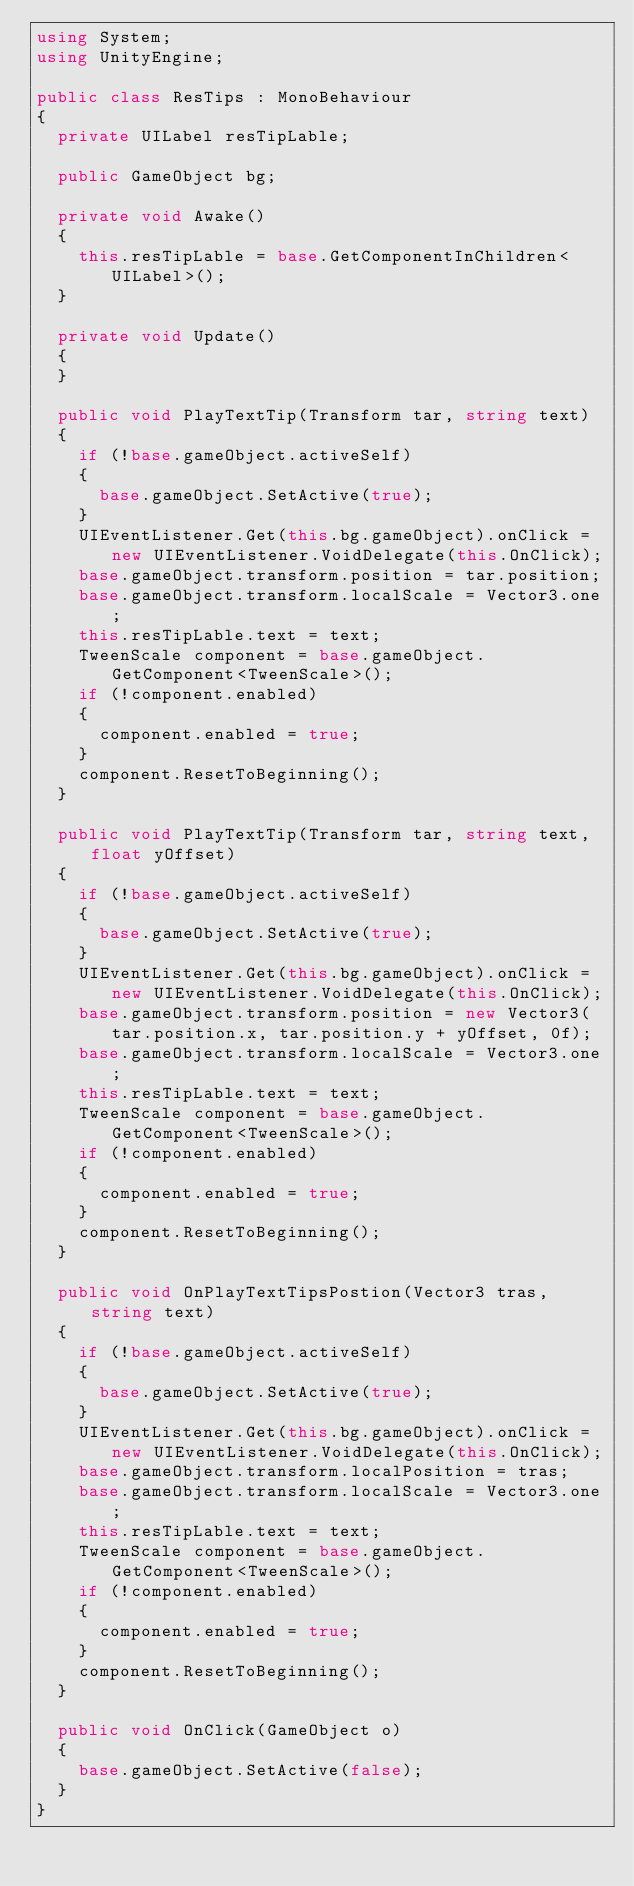Convert code to text. <code><loc_0><loc_0><loc_500><loc_500><_C#_>using System;
using UnityEngine;

public class ResTips : MonoBehaviour
{
	private UILabel resTipLable;

	public GameObject bg;

	private void Awake()
	{
		this.resTipLable = base.GetComponentInChildren<UILabel>();
	}

	private void Update()
	{
	}

	public void PlayTextTip(Transform tar, string text)
	{
		if (!base.gameObject.activeSelf)
		{
			base.gameObject.SetActive(true);
		}
		UIEventListener.Get(this.bg.gameObject).onClick = new UIEventListener.VoidDelegate(this.OnClick);
		base.gameObject.transform.position = tar.position;
		base.gameObject.transform.localScale = Vector3.one;
		this.resTipLable.text = text;
		TweenScale component = base.gameObject.GetComponent<TweenScale>();
		if (!component.enabled)
		{
			component.enabled = true;
		}
		component.ResetToBeginning();
	}

	public void PlayTextTip(Transform tar, string text, float yOffset)
	{
		if (!base.gameObject.activeSelf)
		{
			base.gameObject.SetActive(true);
		}
		UIEventListener.Get(this.bg.gameObject).onClick = new UIEventListener.VoidDelegate(this.OnClick);
		base.gameObject.transform.position = new Vector3(tar.position.x, tar.position.y + yOffset, 0f);
		base.gameObject.transform.localScale = Vector3.one;
		this.resTipLable.text = text;
		TweenScale component = base.gameObject.GetComponent<TweenScale>();
		if (!component.enabled)
		{
			component.enabled = true;
		}
		component.ResetToBeginning();
	}

	public void OnPlayTextTipsPostion(Vector3 tras, string text)
	{
		if (!base.gameObject.activeSelf)
		{
			base.gameObject.SetActive(true);
		}
		UIEventListener.Get(this.bg.gameObject).onClick = new UIEventListener.VoidDelegate(this.OnClick);
		base.gameObject.transform.localPosition = tras;
		base.gameObject.transform.localScale = Vector3.one;
		this.resTipLable.text = text;
		TweenScale component = base.gameObject.GetComponent<TweenScale>();
		if (!component.enabled)
		{
			component.enabled = true;
		}
		component.ResetToBeginning();
	}

	public void OnClick(GameObject o)
	{
		base.gameObject.SetActive(false);
	}
}
</code> 